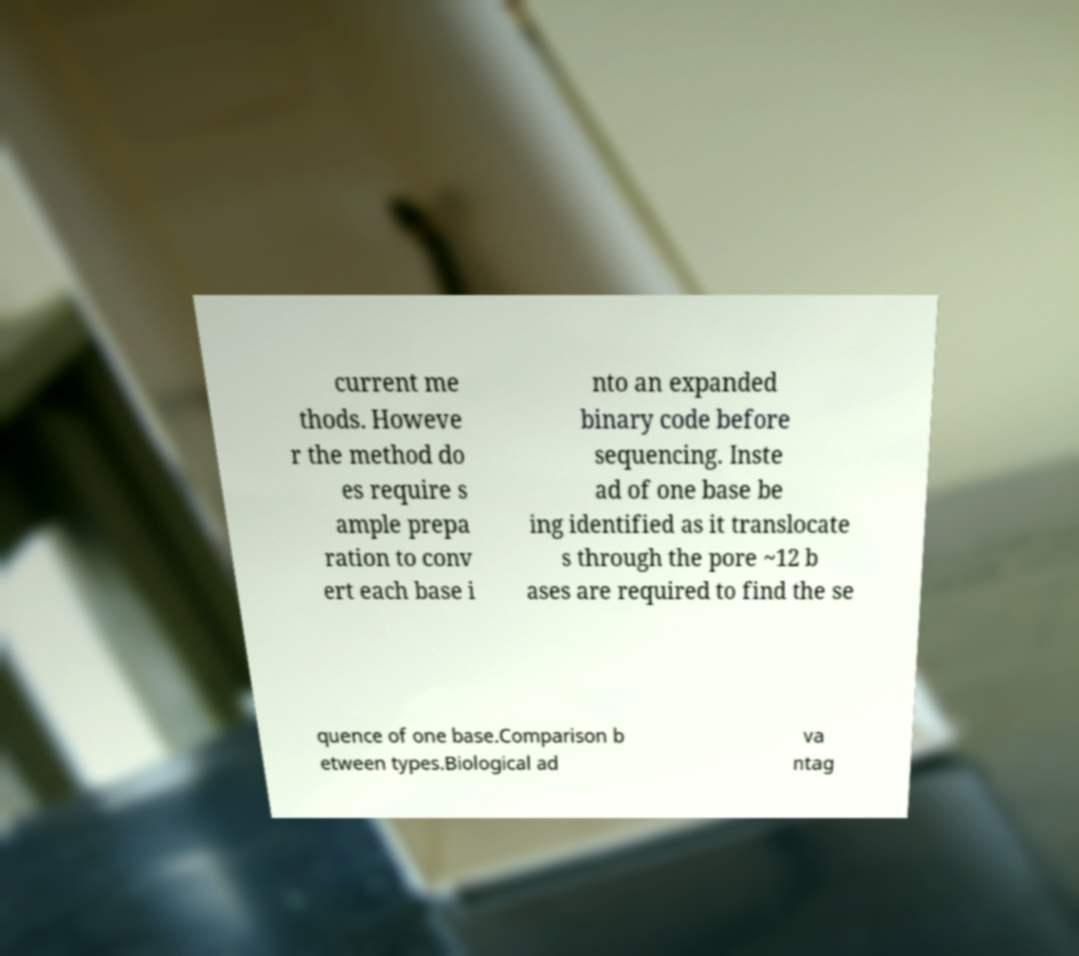Could you assist in decoding the text presented in this image and type it out clearly? current me thods. Howeve r the method do es require s ample prepa ration to conv ert each base i nto an expanded binary code before sequencing. Inste ad of one base be ing identified as it translocate s through the pore ~12 b ases are required to find the se quence of one base.Comparison b etween types.Biological ad va ntag 